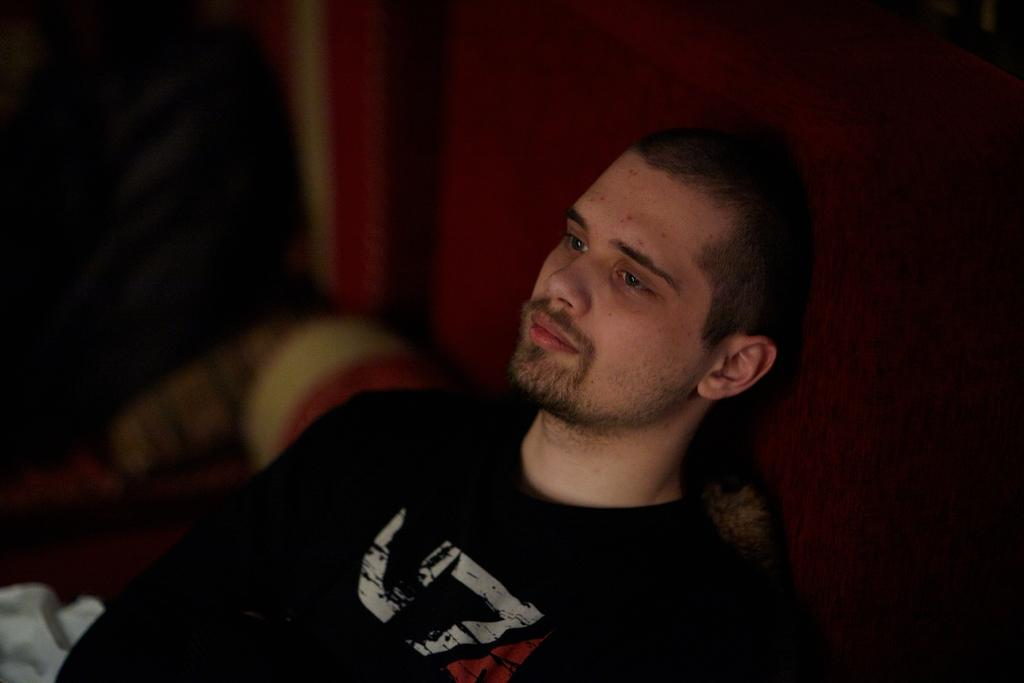What is the main subject of the image? The main subject of the image is a man. What can be observed about the man's attire? The man is wearing clothes. Can you describe the background of the image? The background of the image is dark. What is the temperature of the account mentioned in the image? There is no mention of an account or temperature in the image; it features a man with a dark background. 